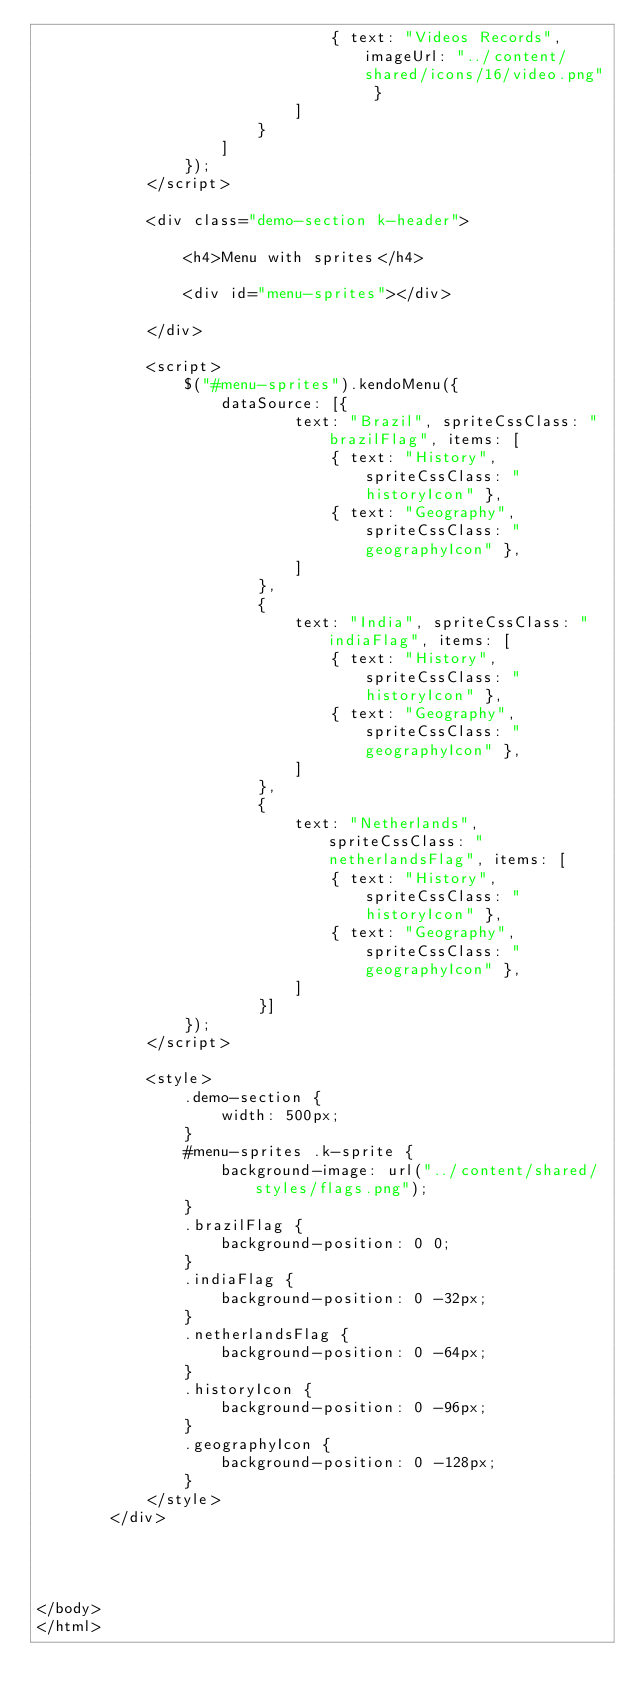Convert code to text. <code><loc_0><loc_0><loc_500><loc_500><_HTML_>                                { text: "Videos Records", imageUrl: "../content/shared/icons/16/video.png" }
                            ]
                        }
                    ]
                });
            </script>

            <div class="demo-section k-header">

                <h4>Menu with sprites</h4>

                <div id="menu-sprites"></div>

            </div>

            <script>
                $("#menu-sprites").kendoMenu({
                    dataSource: [{
                            text: "Brazil", spriteCssClass: "brazilFlag", items: [
                                { text: "History", spriteCssClass: "historyIcon" },
                                { text: "Geography", spriteCssClass: "geographyIcon" },
                            ]
                        },
                        {
                            text: "India", spriteCssClass: "indiaFlag", items: [
                                { text: "History", spriteCssClass: "historyIcon" },
                                { text: "Geography", spriteCssClass: "geographyIcon" },
                            ]
                        },
                        {
                            text: "Netherlands", spriteCssClass: "netherlandsFlag", items: [
                                { text: "History", spriteCssClass: "historyIcon" },
                                { text: "Geography", spriteCssClass: "geographyIcon" },
                            ]
                        }]
                });
            </script>

            <style>
                .demo-section {
                	width: 500px;
                }
                #menu-sprites .k-sprite {
                    background-image: url("../content/shared/styles/flags.png");
                }
                .brazilFlag {
                	background-position: 0 0;
                }
                .indiaFlag {
                	background-position: 0 -32px;
                }
                .netherlandsFlag {
                	background-position: 0 -64px;
                }
                .historyIcon {
                	background-position: 0 -96px;
                }
                .geographyIcon {
                	background-position: 0 -128px;
                }
            </style>
        </div>


    
    
</body>
</html>
</code> 